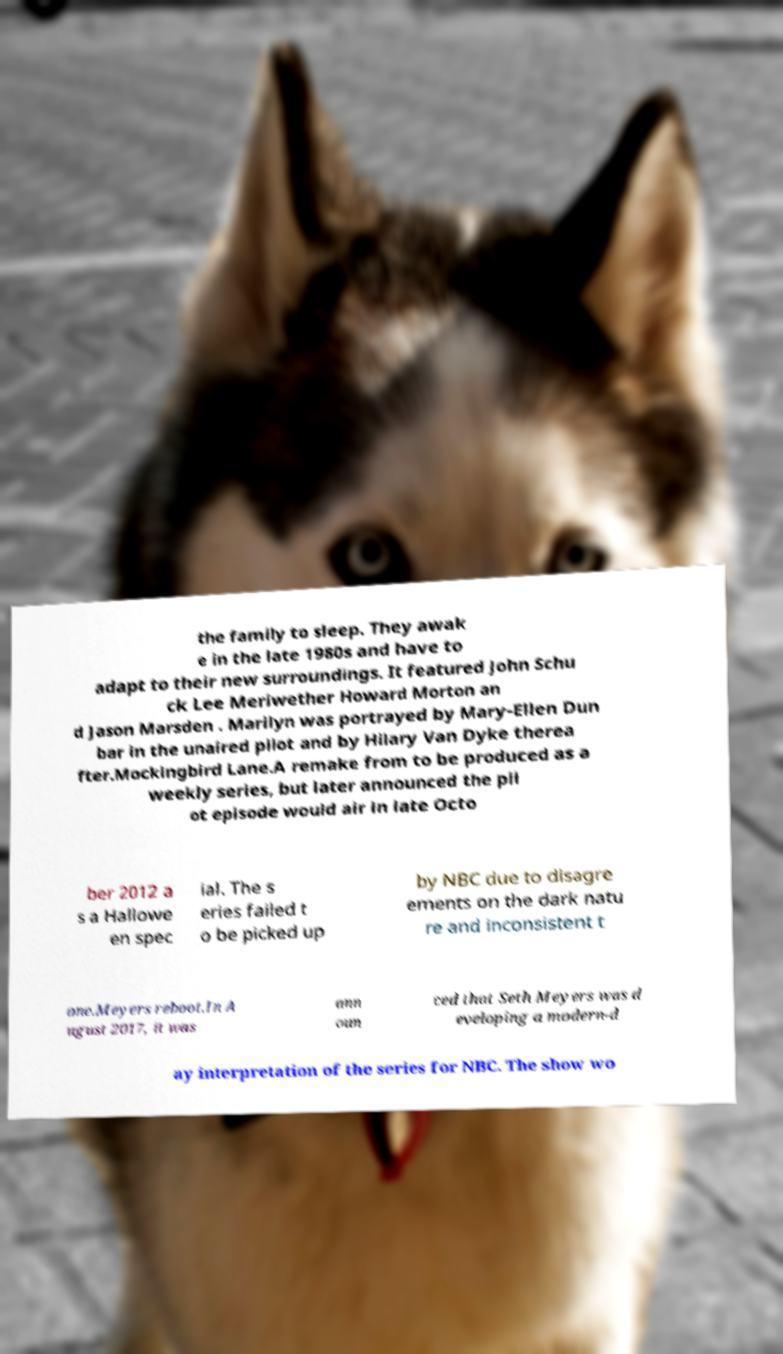Can you accurately transcribe the text from the provided image for me? the family to sleep. They awak e in the late 1980s and have to adapt to their new surroundings. It featured John Schu ck Lee Meriwether Howard Morton an d Jason Marsden . Marilyn was portrayed by Mary-Ellen Dun bar in the unaired pilot and by Hilary Van Dyke therea fter.Mockingbird Lane.A remake from to be produced as a weekly series, but later announced the pil ot episode would air in late Octo ber 2012 a s a Hallowe en spec ial. The s eries failed t o be picked up by NBC due to disagre ements on the dark natu re and inconsistent t one.Meyers reboot.In A ugust 2017, it was ann oun ced that Seth Meyers was d eveloping a modern-d ay interpretation of the series for NBC. The show wo 